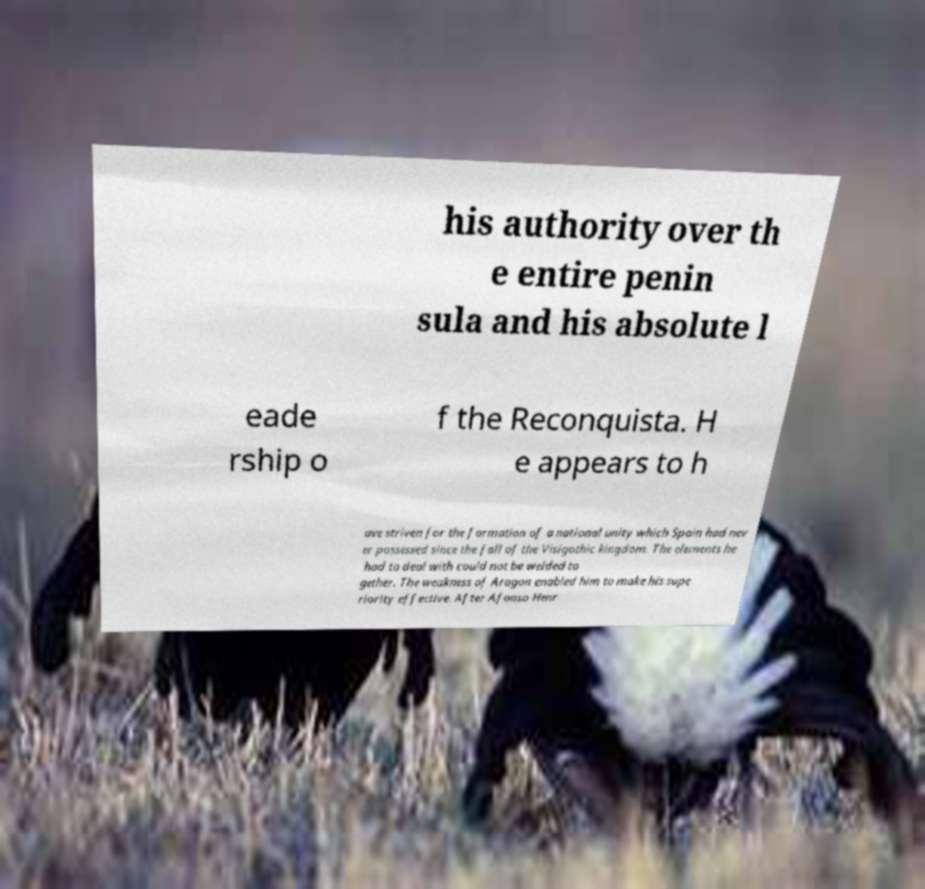Please identify and transcribe the text found in this image. his authority over th e entire penin sula and his absolute l eade rship o f the Reconquista. H e appears to h ave striven for the formation of a national unity which Spain had nev er possessed since the fall of the Visigothic kingdom. The elements he had to deal with could not be welded to gether. The weakness of Aragon enabled him to make his supe riority effective. After Afonso Henr 